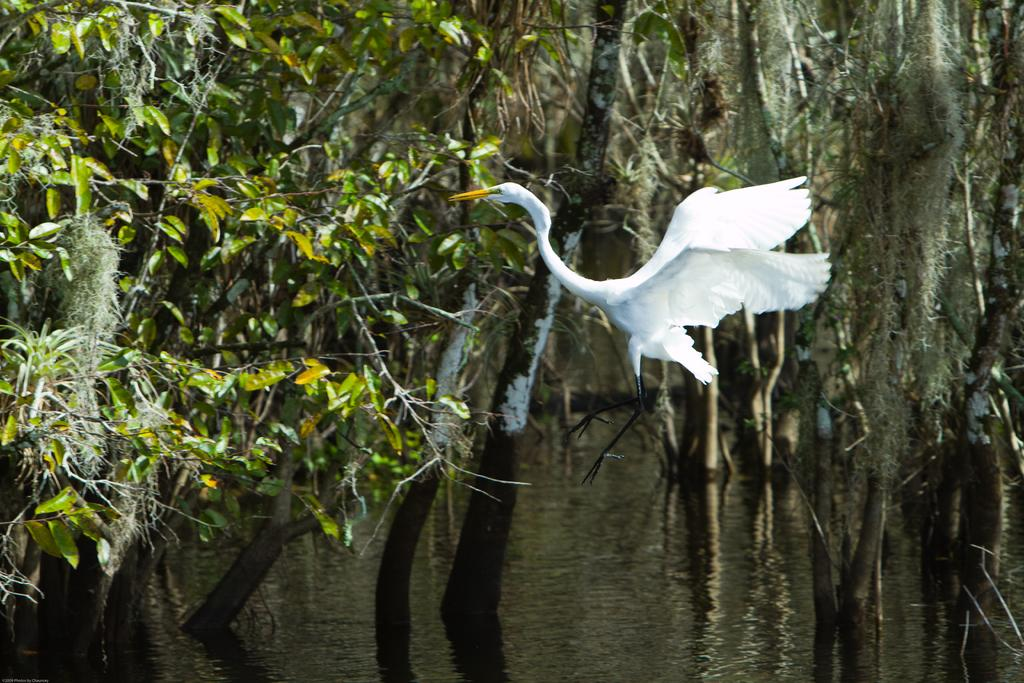What is the main subject of the image? There is a bird flying in the image. What can be seen in the background of the image? Leaves and branches are visible in the background of the image. What is present at the bottom portion of the image? There is water at the bottom portion of the image. How many eyes does the bird have on its sense of scissors in the image? There are no scissors or references to senses in the image, and the bird's eyes cannot be counted as they are not visible in the image. 